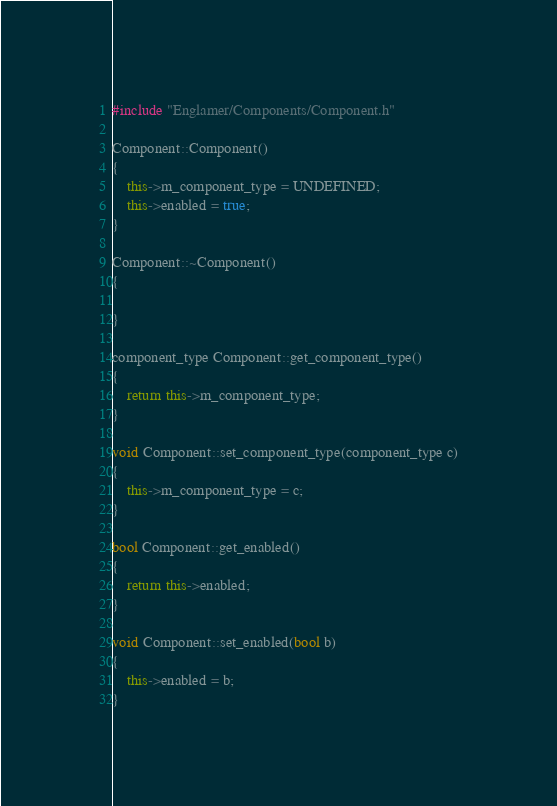<code> <loc_0><loc_0><loc_500><loc_500><_C++_>#include "Englamer/Components/Component.h"

Component::Component()
{
	this->m_component_type = UNDEFINED;
	this->enabled = true;
}

Component::~Component()
{

}

component_type Component::get_component_type()
{
	return this->m_component_type;
}

void Component::set_component_type(component_type c)
{
	this->m_component_type = c;
}

bool Component::get_enabled()
{
	return this->enabled;
}

void Component::set_enabled(bool b)
{
	this->enabled = b;
}
</code> 